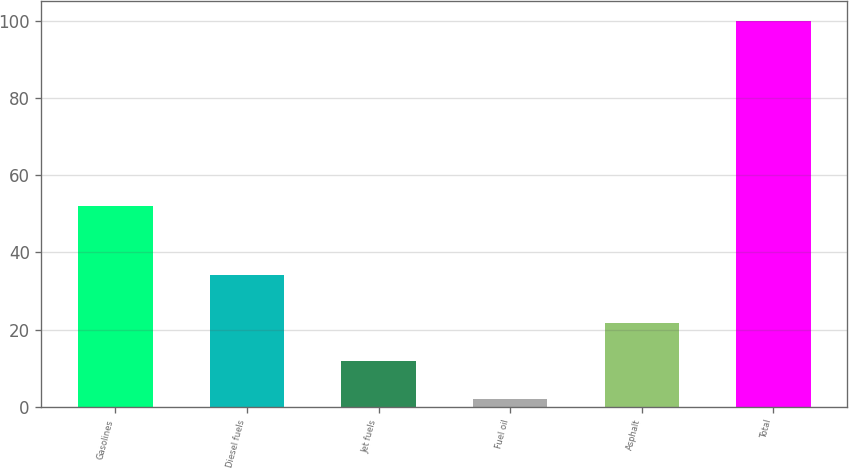Convert chart. <chart><loc_0><loc_0><loc_500><loc_500><bar_chart><fcel>Gasolines<fcel>Diesel fuels<fcel>Jet fuels<fcel>Fuel oil<fcel>Asphalt<fcel>Total<nl><fcel>52<fcel>34<fcel>11.8<fcel>2<fcel>21.6<fcel>100<nl></chart> 